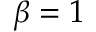Convert formula to latex. <formula><loc_0><loc_0><loc_500><loc_500>\beta = 1</formula> 